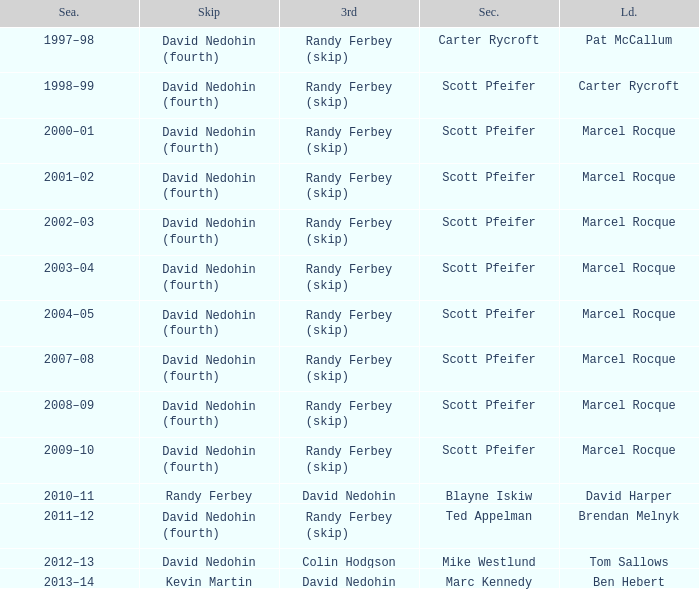Which Season has a Third of colin hodgson? 2012–13. 